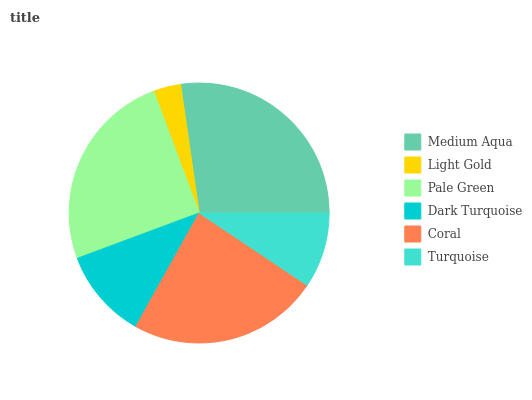Is Light Gold the minimum?
Answer yes or no. Yes. Is Medium Aqua the maximum?
Answer yes or no. Yes. Is Pale Green the minimum?
Answer yes or no. No. Is Pale Green the maximum?
Answer yes or no. No. Is Pale Green greater than Light Gold?
Answer yes or no. Yes. Is Light Gold less than Pale Green?
Answer yes or no. Yes. Is Light Gold greater than Pale Green?
Answer yes or no. No. Is Pale Green less than Light Gold?
Answer yes or no. No. Is Coral the high median?
Answer yes or no. Yes. Is Dark Turquoise the low median?
Answer yes or no. Yes. Is Light Gold the high median?
Answer yes or no. No. Is Coral the low median?
Answer yes or no. No. 